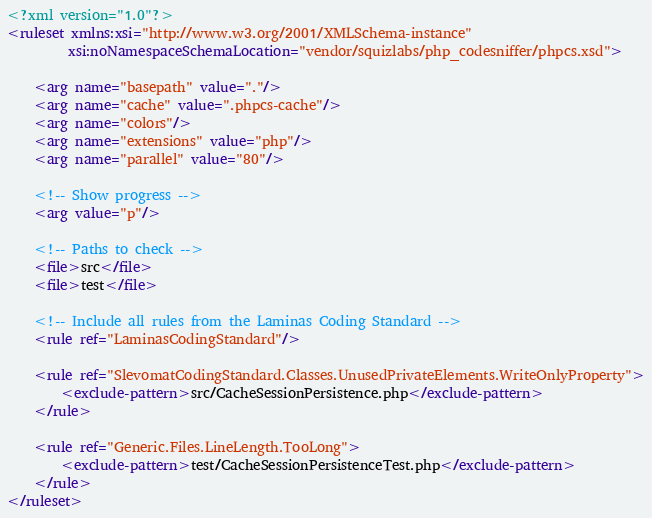Convert code to text. <code><loc_0><loc_0><loc_500><loc_500><_XML_><?xml version="1.0"?>
<ruleset xmlns:xsi="http://www.w3.org/2001/XMLSchema-instance"
         xsi:noNamespaceSchemaLocation="vendor/squizlabs/php_codesniffer/phpcs.xsd">

    <arg name="basepath" value="."/>
    <arg name="cache" value=".phpcs-cache"/>
    <arg name="colors"/>
    <arg name="extensions" value="php"/>
    <arg name="parallel" value="80"/>
    
    <!-- Show progress -->
    <arg value="p"/>

    <!-- Paths to check -->
    <file>src</file>
    <file>test</file>

    <!-- Include all rules from the Laminas Coding Standard -->
    <rule ref="LaminasCodingStandard"/>

    <rule ref="SlevomatCodingStandard.Classes.UnusedPrivateElements.WriteOnlyProperty">
        <exclude-pattern>src/CacheSessionPersistence.php</exclude-pattern>
    </rule>

    <rule ref="Generic.Files.LineLength.TooLong">
        <exclude-pattern>test/CacheSessionPersistenceTest.php</exclude-pattern>
    </rule>
</ruleset>
</code> 